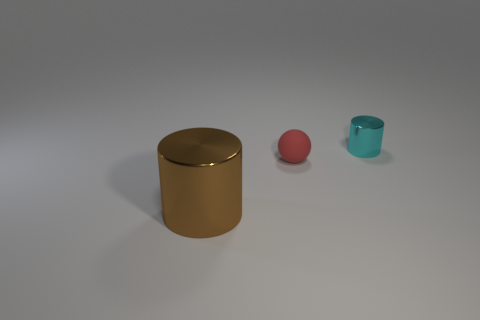What possible uses could these objects have? The large cylindrical object could be a container or a decorative piece. The small pink ball might be used as a child's toy or a stress-relief object, and the tiny cyan cylinder could serve as a small cup or a holder for small items, depending on its actual size and material. 